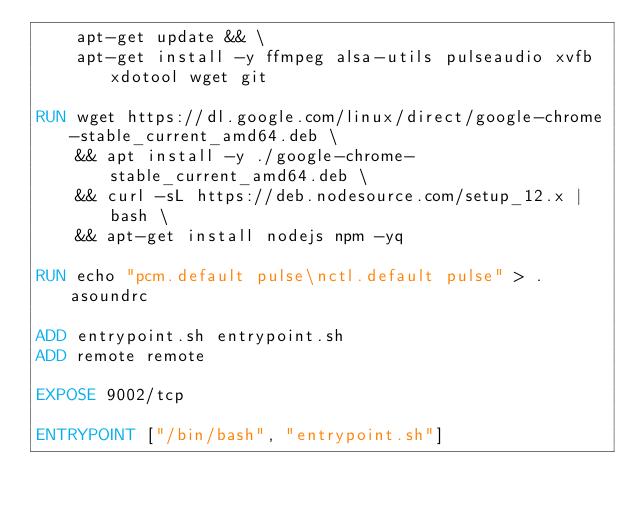Convert code to text. <code><loc_0><loc_0><loc_500><loc_500><_Dockerfile_>    apt-get update && \
    apt-get install -y ffmpeg alsa-utils pulseaudio xvfb xdotool wget git

RUN wget https://dl.google.com/linux/direct/google-chrome-stable_current_amd64.deb \
    && apt install -y ./google-chrome-stable_current_amd64.deb \
    && curl -sL https://deb.nodesource.com/setup_12.x | bash \
    && apt-get install nodejs npm -yq

RUN echo "pcm.default pulse\nctl.default pulse" > .asoundrc

ADD entrypoint.sh entrypoint.sh
ADD remote remote

EXPOSE 9002/tcp

ENTRYPOINT ["/bin/bash", "entrypoint.sh"]
</code> 